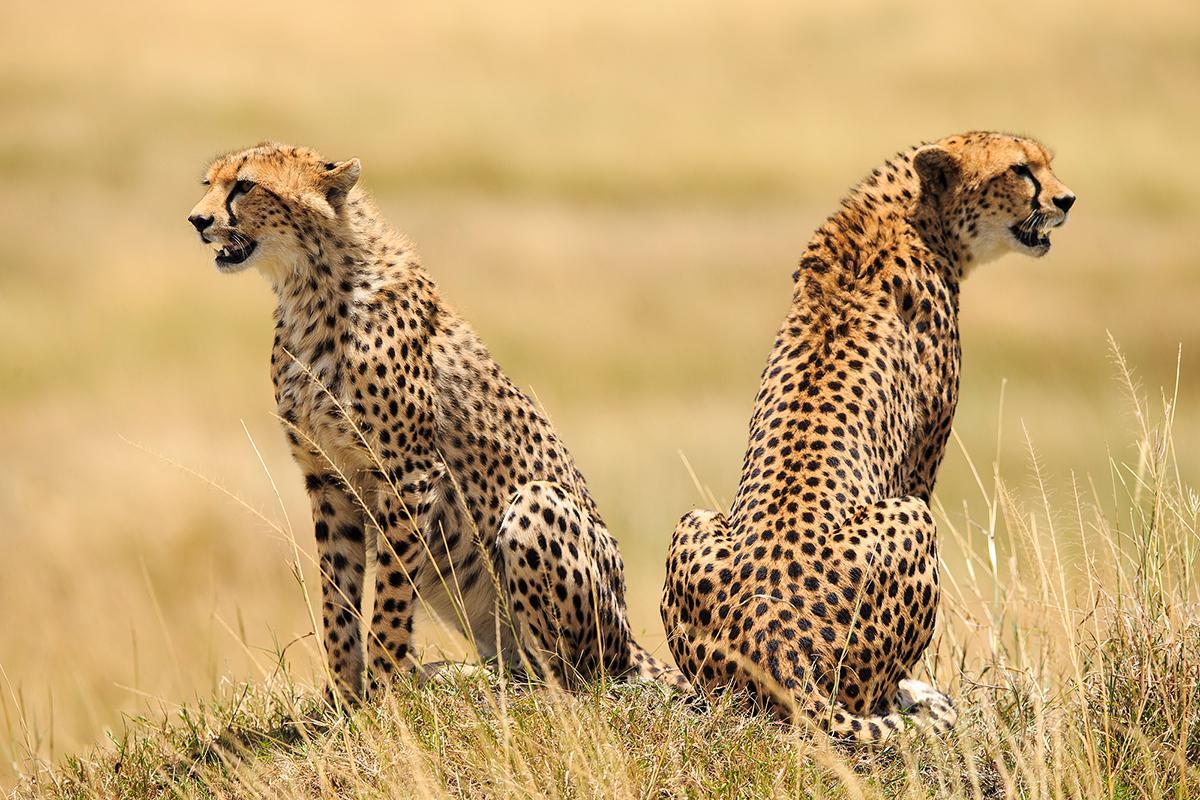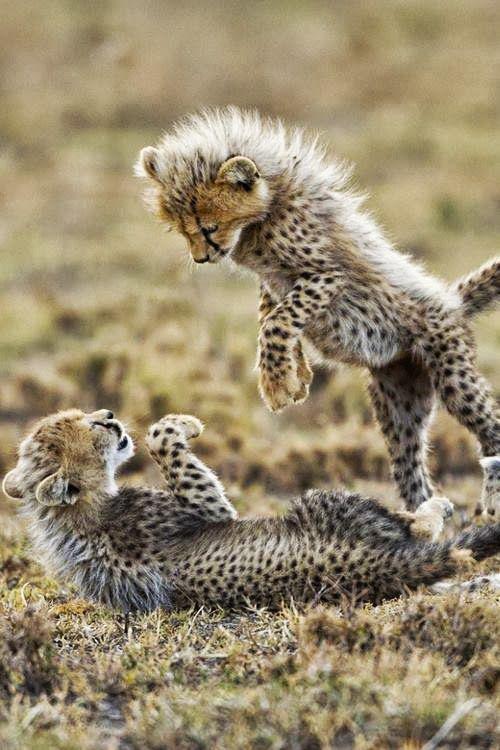The first image is the image on the left, the second image is the image on the right. Analyze the images presented: Is the assertion "One image contains two cheetah kittens and one adult cheetah, and one of the kittens is standing on its hind legs so its head is nearly even with the upright adult cat." valid? Answer yes or no. No. The first image is the image on the left, the second image is the image on the right. Examine the images to the left and right. Is the description "One image shows only adult cheetahs and the other shows one adult cheetah with two young cheetahs." accurate? Answer yes or no. No. 